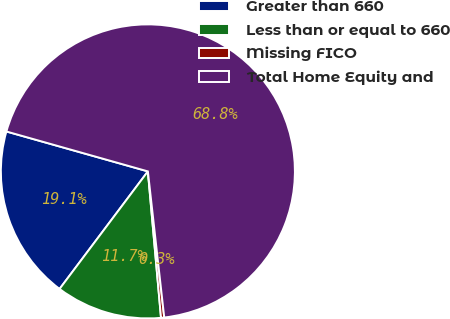Convert chart to OTSL. <chart><loc_0><loc_0><loc_500><loc_500><pie_chart><fcel>Greater than 660<fcel>Less than or equal to 660<fcel>Missing FICO<fcel>Total Home Equity and<nl><fcel>19.12%<fcel>11.68%<fcel>0.35%<fcel>68.85%<nl></chart> 